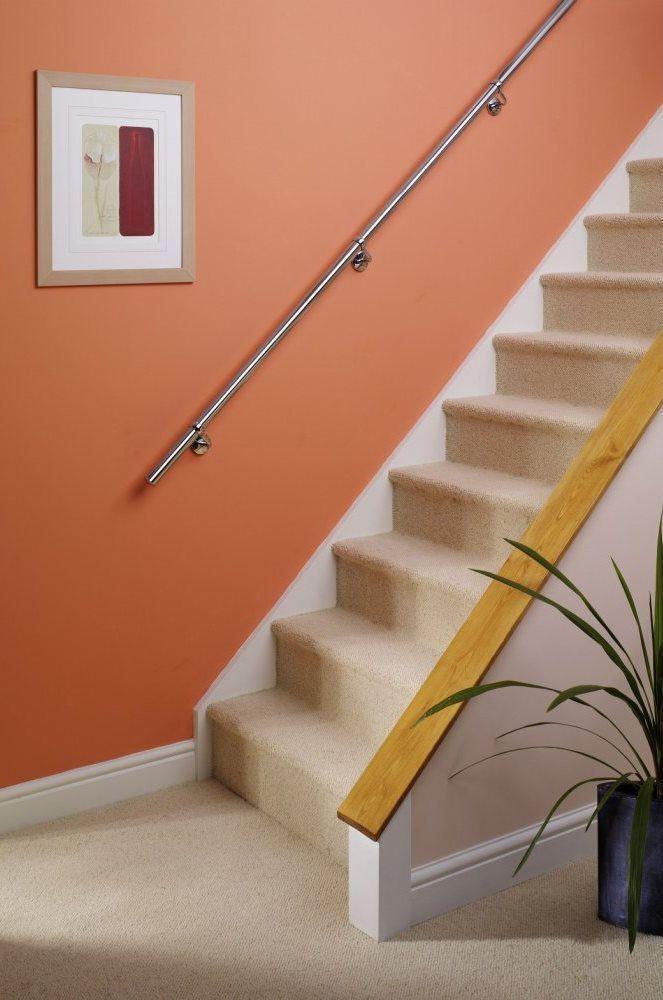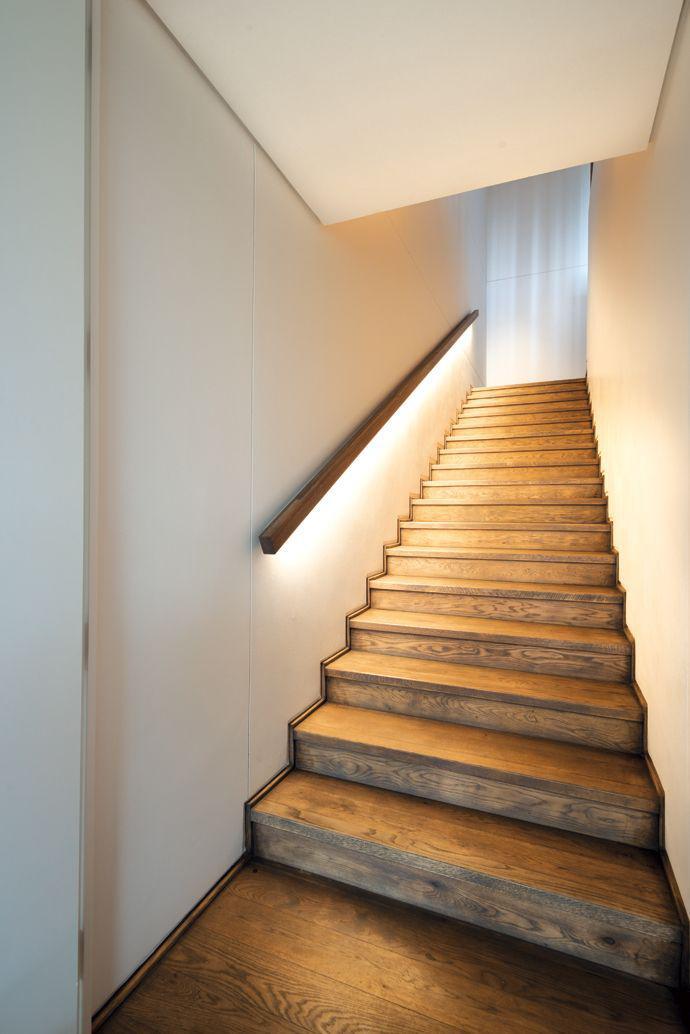The first image is the image on the left, the second image is the image on the right. Evaluate the accuracy of this statement regarding the images: "The plant in the image on the left is sitting beside the stairway.". Is it true? Answer yes or no. Yes. 